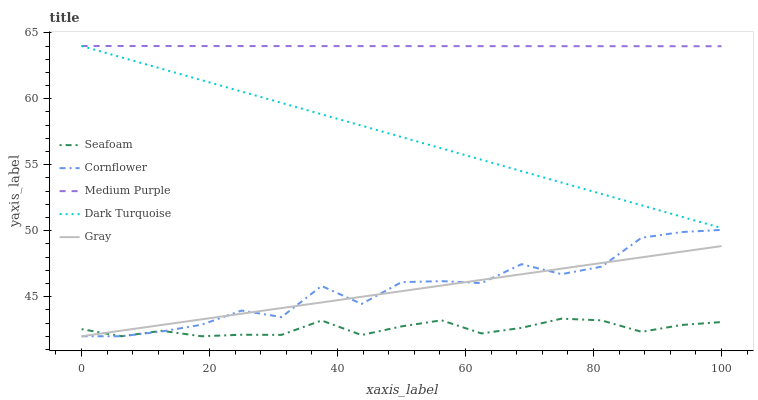Does Seafoam have the minimum area under the curve?
Answer yes or no. Yes. Does Medium Purple have the maximum area under the curve?
Answer yes or no. Yes. Does Cornflower have the minimum area under the curve?
Answer yes or no. No. Does Cornflower have the maximum area under the curve?
Answer yes or no. No. Is Medium Purple the smoothest?
Answer yes or no. Yes. Is Cornflower the roughest?
Answer yes or no. Yes. Is Gray the smoothest?
Answer yes or no. No. Is Gray the roughest?
Answer yes or no. No. Does Cornflower have the lowest value?
Answer yes or no. Yes. Does Dark Turquoise have the lowest value?
Answer yes or no. No. Does Dark Turquoise have the highest value?
Answer yes or no. Yes. Does Cornflower have the highest value?
Answer yes or no. No. Is Cornflower less than Medium Purple?
Answer yes or no. Yes. Is Medium Purple greater than Gray?
Answer yes or no. Yes. Does Seafoam intersect Cornflower?
Answer yes or no. Yes. Is Seafoam less than Cornflower?
Answer yes or no. No. Is Seafoam greater than Cornflower?
Answer yes or no. No. Does Cornflower intersect Medium Purple?
Answer yes or no. No. 